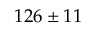<formula> <loc_0><loc_0><loc_500><loc_500>1 2 6 \pm 1 1</formula> 